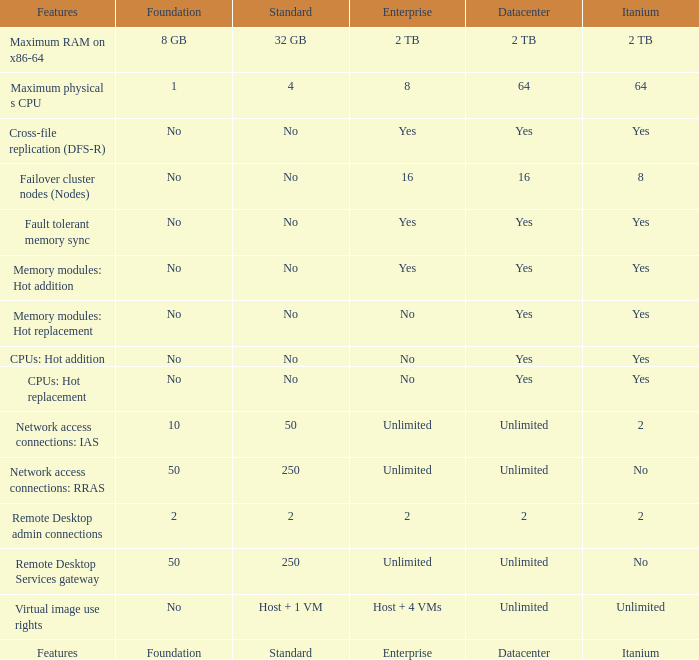What enterprise feature allows for memory modules to be hot-replaced and is associated with a data center with a "yes" confirmation? No. 